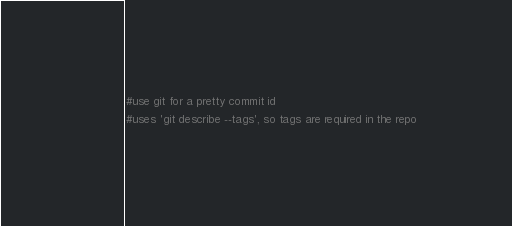Convert code to text. <code><loc_0><loc_0><loc_500><loc_500><_CMake_>#use git for a pretty commit id
#uses 'git describe --tags', so tags are required in the repo</code> 